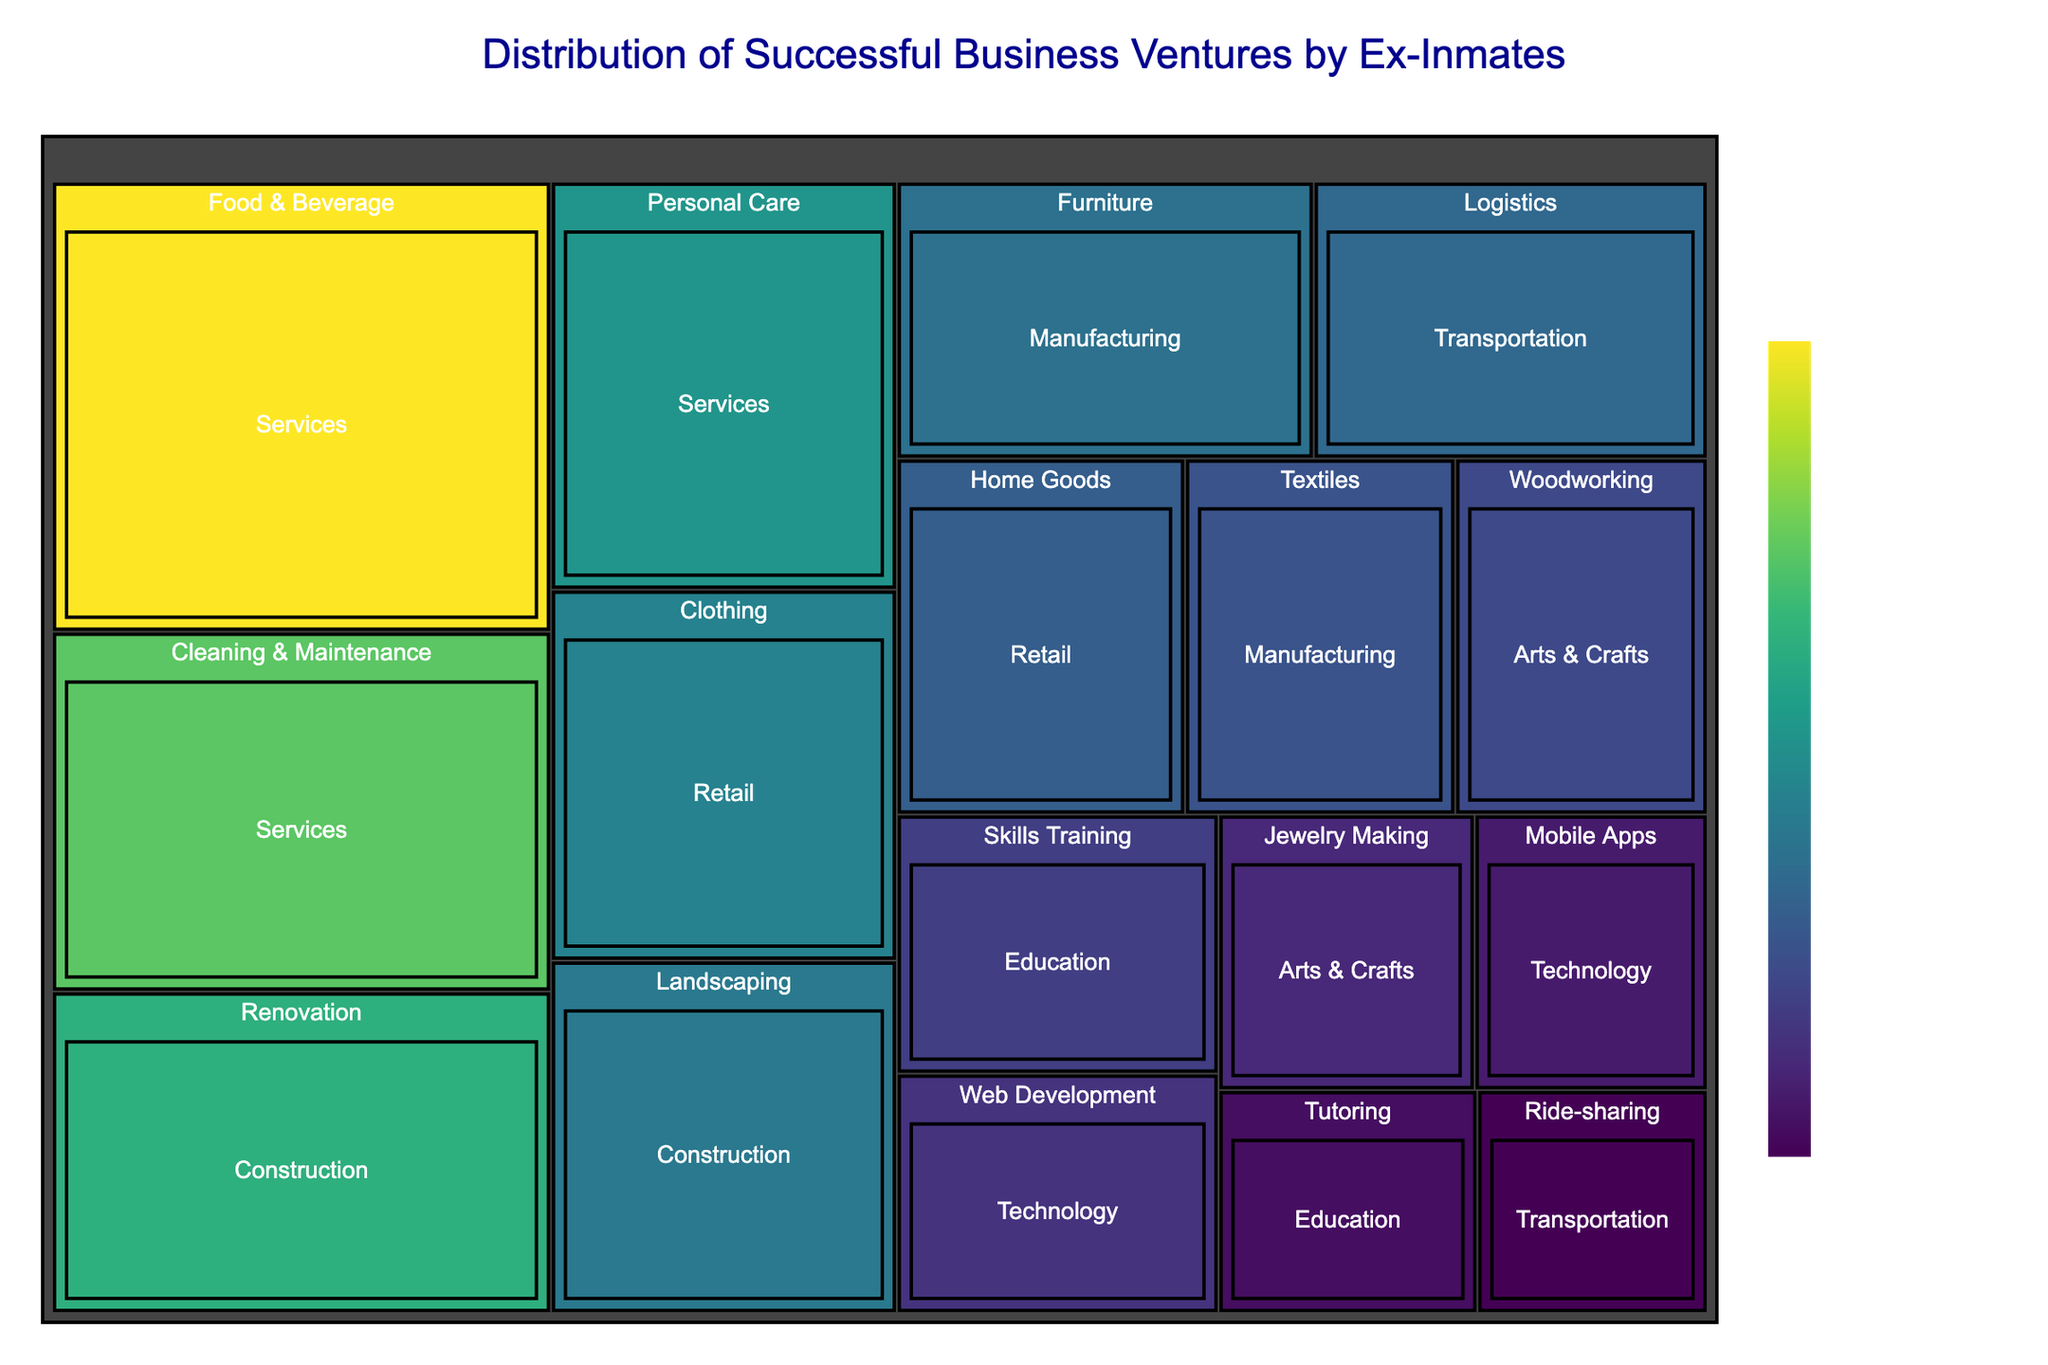What's the title of the treemap? The title is usually located at the top of the treemap and summarizes what the chart is about. The title "Distribution of Successful Business Ventures by Ex-Inmates" signifies that the chart displays the proportion of various successful business ventures initiated by former inmates, classified by industry sectors.
Answer: Distribution of Successful Business Ventures by Ex-Inmates Which sector has the highest number of ventures? Identify the sector that appears the largest in the treemap, implying it has the highest number of ventures. The Services sector stands out as the largest section.
Answer: Services How many ventures are there in the Web Development industry? Find the Web Development industry segment within the Technology sector on the treemap and read the value. The Web Development sector shows a value of 12 ventures.
Answer: 12 Sum the number of ventures in the Food & Beverage and Cleaning & Maintenance industries. Locate both the Food & Beverage and Cleaning & Maintenance industries within the Services sector on the treemap and add the values together: Food & Beverage has 35 ventures, and Cleaning & Maintenance has 28 ventures. Therefore, 35 + 28 = 63.
Answer: 63 Which sector has more ventures: Construction or Technology? Identify the segments for Construction and Technology sectors on the treemap, compare their sizes, and verify their values: Construction has 25 (Renovation) + 19 (Landscaping) = 44, and Technology has 12 (Web Development) + 10 (Mobile Apps) = 22. Construction has more ventures than Technology.
Answer: Construction What is the difference in the number of ventures between Textiles and Clothing industries? Locate the Textiles industry in the Manufacturing sector and the Clothing industry in the Retail sector on the treemap and calculate the difference in their values: Textiles has 15 ventures, and Clothing has 20 ventures. Thus, 20 - 15 = 5.
Answer: 5 Which industry within the Services sector has the least number of ventures? Identify and compare the industries within the Services sector on the treemap and find the one with the lowest value. Personal Care has 22 ventures, which is the least among the industries in the Services sector.
Answer: Personal Care Which category does the largest number of ventures fall under? Identify which entire segment (sector or industry within a sector) occupies the largest area on the treemap. The Services sector is the most extensive category representing the largest number of ventures.
Answer: Services How many ventures are in the Arts & Crafts sector? Locate the Arts & Crafts sector on the treemap, sum the values of its industries: Woodworking (14) and Jewelry Making (11). Hence, 14 + 11 = 25.
Answer: 25 Compare the number of ventures in the Home Goods and Logistics industries. Which one has more? Find the Home Goods industry in the Retail sector and Logistics industry in the Transportation sector on the treemap, then compare their values: Home Goods has 16 ventures, and Logistics has 17 ventures. Logistics has more ventures than Home Goods.
Answer: Logistics 